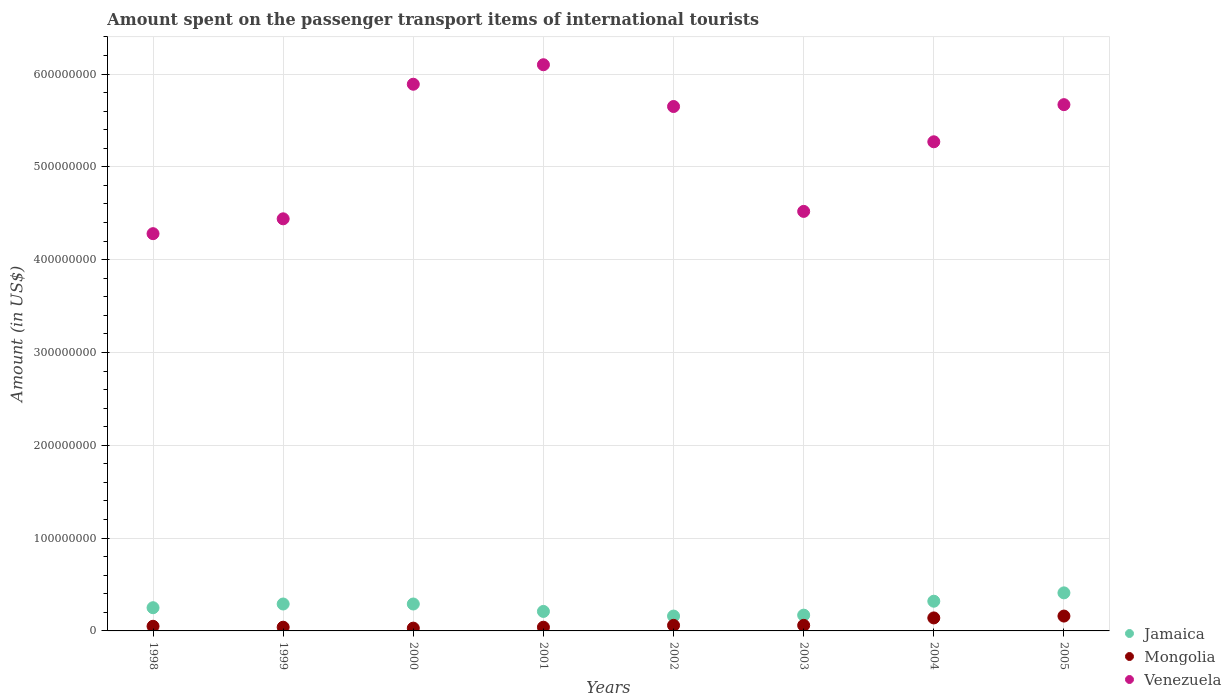How many different coloured dotlines are there?
Your response must be concise. 3. What is the amount spent on the passenger transport items of international tourists in Jamaica in 1998?
Ensure brevity in your answer.  2.50e+07. Across all years, what is the maximum amount spent on the passenger transport items of international tourists in Jamaica?
Your answer should be compact. 4.10e+07. Across all years, what is the minimum amount spent on the passenger transport items of international tourists in Jamaica?
Your answer should be very brief. 1.60e+07. In which year was the amount spent on the passenger transport items of international tourists in Venezuela minimum?
Your answer should be very brief. 1998. What is the total amount spent on the passenger transport items of international tourists in Jamaica in the graph?
Your response must be concise. 2.10e+08. What is the difference between the amount spent on the passenger transport items of international tourists in Mongolia in 2004 and the amount spent on the passenger transport items of international tourists in Jamaica in 1999?
Give a very brief answer. -1.50e+07. What is the average amount spent on the passenger transport items of international tourists in Venezuela per year?
Offer a terse response. 5.23e+08. In the year 2000, what is the difference between the amount spent on the passenger transport items of international tourists in Venezuela and amount spent on the passenger transport items of international tourists in Jamaica?
Provide a succinct answer. 5.60e+08. In how many years, is the amount spent on the passenger transport items of international tourists in Mongolia greater than 240000000 US$?
Offer a terse response. 0. What is the ratio of the amount spent on the passenger transport items of international tourists in Jamaica in 2003 to that in 2005?
Provide a short and direct response. 0.41. Is the amount spent on the passenger transport items of international tourists in Mongolia in 2000 less than that in 2002?
Make the answer very short. Yes. Is the difference between the amount spent on the passenger transport items of international tourists in Venezuela in 2000 and 2001 greater than the difference between the amount spent on the passenger transport items of international tourists in Jamaica in 2000 and 2001?
Give a very brief answer. No. What is the difference between the highest and the lowest amount spent on the passenger transport items of international tourists in Venezuela?
Give a very brief answer. 1.82e+08. Is the sum of the amount spent on the passenger transport items of international tourists in Jamaica in 2003 and 2004 greater than the maximum amount spent on the passenger transport items of international tourists in Mongolia across all years?
Your answer should be very brief. Yes. Is it the case that in every year, the sum of the amount spent on the passenger transport items of international tourists in Mongolia and amount spent on the passenger transport items of international tourists in Venezuela  is greater than the amount spent on the passenger transport items of international tourists in Jamaica?
Ensure brevity in your answer.  Yes. How many dotlines are there?
Make the answer very short. 3. Are the values on the major ticks of Y-axis written in scientific E-notation?
Your answer should be very brief. No. Does the graph contain grids?
Your response must be concise. Yes. Where does the legend appear in the graph?
Keep it short and to the point. Bottom right. How many legend labels are there?
Your answer should be compact. 3. How are the legend labels stacked?
Your answer should be very brief. Vertical. What is the title of the graph?
Offer a terse response. Amount spent on the passenger transport items of international tourists. What is the label or title of the X-axis?
Give a very brief answer. Years. What is the Amount (in US$) in Jamaica in 1998?
Your answer should be very brief. 2.50e+07. What is the Amount (in US$) of Venezuela in 1998?
Offer a terse response. 4.28e+08. What is the Amount (in US$) in Jamaica in 1999?
Provide a succinct answer. 2.90e+07. What is the Amount (in US$) in Venezuela in 1999?
Provide a short and direct response. 4.44e+08. What is the Amount (in US$) in Jamaica in 2000?
Offer a very short reply. 2.90e+07. What is the Amount (in US$) in Mongolia in 2000?
Offer a terse response. 3.00e+06. What is the Amount (in US$) of Venezuela in 2000?
Your response must be concise. 5.89e+08. What is the Amount (in US$) of Jamaica in 2001?
Your answer should be very brief. 2.10e+07. What is the Amount (in US$) in Venezuela in 2001?
Ensure brevity in your answer.  6.10e+08. What is the Amount (in US$) in Jamaica in 2002?
Ensure brevity in your answer.  1.60e+07. What is the Amount (in US$) of Mongolia in 2002?
Give a very brief answer. 6.00e+06. What is the Amount (in US$) in Venezuela in 2002?
Offer a very short reply. 5.65e+08. What is the Amount (in US$) of Jamaica in 2003?
Offer a very short reply. 1.70e+07. What is the Amount (in US$) of Mongolia in 2003?
Your answer should be compact. 6.00e+06. What is the Amount (in US$) in Venezuela in 2003?
Make the answer very short. 4.52e+08. What is the Amount (in US$) in Jamaica in 2004?
Provide a succinct answer. 3.20e+07. What is the Amount (in US$) in Mongolia in 2004?
Your answer should be compact. 1.40e+07. What is the Amount (in US$) in Venezuela in 2004?
Make the answer very short. 5.27e+08. What is the Amount (in US$) in Jamaica in 2005?
Give a very brief answer. 4.10e+07. What is the Amount (in US$) in Mongolia in 2005?
Make the answer very short. 1.60e+07. What is the Amount (in US$) in Venezuela in 2005?
Offer a terse response. 5.67e+08. Across all years, what is the maximum Amount (in US$) of Jamaica?
Your answer should be very brief. 4.10e+07. Across all years, what is the maximum Amount (in US$) in Mongolia?
Keep it short and to the point. 1.60e+07. Across all years, what is the maximum Amount (in US$) of Venezuela?
Make the answer very short. 6.10e+08. Across all years, what is the minimum Amount (in US$) in Jamaica?
Offer a very short reply. 1.60e+07. Across all years, what is the minimum Amount (in US$) in Mongolia?
Ensure brevity in your answer.  3.00e+06. Across all years, what is the minimum Amount (in US$) of Venezuela?
Provide a short and direct response. 4.28e+08. What is the total Amount (in US$) in Jamaica in the graph?
Keep it short and to the point. 2.10e+08. What is the total Amount (in US$) of Mongolia in the graph?
Your answer should be compact. 5.80e+07. What is the total Amount (in US$) of Venezuela in the graph?
Keep it short and to the point. 4.18e+09. What is the difference between the Amount (in US$) in Mongolia in 1998 and that in 1999?
Make the answer very short. 1.00e+06. What is the difference between the Amount (in US$) of Venezuela in 1998 and that in 1999?
Your response must be concise. -1.60e+07. What is the difference between the Amount (in US$) in Jamaica in 1998 and that in 2000?
Make the answer very short. -4.00e+06. What is the difference between the Amount (in US$) in Mongolia in 1998 and that in 2000?
Your response must be concise. 2.00e+06. What is the difference between the Amount (in US$) in Venezuela in 1998 and that in 2000?
Your response must be concise. -1.61e+08. What is the difference between the Amount (in US$) of Jamaica in 1998 and that in 2001?
Provide a short and direct response. 4.00e+06. What is the difference between the Amount (in US$) of Mongolia in 1998 and that in 2001?
Keep it short and to the point. 1.00e+06. What is the difference between the Amount (in US$) of Venezuela in 1998 and that in 2001?
Your answer should be compact. -1.82e+08. What is the difference between the Amount (in US$) in Jamaica in 1998 and that in 2002?
Provide a succinct answer. 9.00e+06. What is the difference between the Amount (in US$) of Venezuela in 1998 and that in 2002?
Your answer should be compact. -1.37e+08. What is the difference between the Amount (in US$) in Mongolia in 1998 and that in 2003?
Offer a very short reply. -1.00e+06. What is the difference between the Amount (in US$) of Venezuela in 1998 and that in 2003?
Ensure brevity in your answer.  -2.40e+07. What is the difference between the Amount (in US$) of Jamaica in 1998 and that in 2004?
Ensure brevity in your answer.  -7.00e+06. What is the difference between the Amount (in US$) in Mongolia in 1998 and that in 2004?
Keep it short and to the point. -9.00e+06. What is the difference between the Amount (in US$) in Venezuela in 1998 and that in 2004?
Offer a terse response. -9.90e+07. What is the difference between the Amount (in US$) in Jamaica in 1998 and that in 2005?
Offer a terse response. -1.60e+07. What is the difference between the Amount (in US$) in Mongolia in 1998 and that in 2005?
Offer a very short reply. -1.10e+07. What is the difference between the Amount (in US$) in Venezuela in 1998 and that in 2005?
Give a very brief answer. -1.39e+08. What is the difference between the Amount (in US$) of Jamaica in 1999 and that in 2000?
Offer a terse response. 0. What is the difference between the Amount (in US$) of Venezuela in 1999 and that in 2000?
Provide a succinct answer. -1.45e+08. What is the difference between the Amount (in US$) in Venezuela in 1999 and that in 2001?
Your answer should be compact. -1.66e+08. What is the difference between the Amount (in US$) of Jamaica in 1999 and that in 2002?
Offer a very short reply. 1.30e+07. What is the difference between the Amount (in US$) in Mongolia in 1999 and that in 2002?
Your response must be concise. -2.00e+06. What is the difference between the Amount (in US$) in Venezuela in 1999 and that in 2002?
Ensure brevity in your answer.  -1.21e+08. What is the difference between the Amount (in US$) of Mongolia in 1999 and that in 2003?
Offer a terse response. -2.00e+06. What is the difference between the Amount (in US$) in Venezuela in 1999 and that in 2003?
Offer a terse response. -8.00e+06. What is the difference between the Amount (in US$) in Mongolia in 1999 and that in 2004?
Your answer should be compact. -1.00e+07. What is the difference between the Amount (in US$) in Venezuela in 1999 and that in 2004?
Ensure brevity in your answer.  -8.30e+07. What is the difference between the Amount (in US$) of Jamaica in 1999 and that in 2005?
Your answer should be very brief. -1.20e+07. What is the difference between the Amount (in US$) of Mongolia in 1999 and that in 2005?
Give a very brief answer. -1.20e+07. What is the difference between the Amount (in US$) of Venezuela in 1999 and that in 2005?
Keep it short and to the point. -1.23e+08. What is the difference between the Amount (in US$) of Jamaica in 2000 and that in 2001?
Offer a terse response. 8.00e+06. What is the difference between the Amount (in US$) of Mongolia in 2000 and that in 2001?
Ensure brevity in your answer.  -1.00e+06. What is the difference between the Amount (in US$) of Venezuela in 2000 and that in 2001?
Your answer should be compact. -2.10e+07. What is the difference between the Amount (in US$) in Jamaica in 2000 and that in 2002?
Keep it short and to the point. 1.30e+07. What is the difference between the Amount (in US$) of Mongolia in 2000 and that in 2002?
Provide a succinct answer. -3.00e+06. What is the difference between the Amount (in US$) of Venezuela in 2000 and that in 2002?
Your answer should be very brief. 2.40e+07. What is the difference between the Amount (in US$) in Mongolia in 2000 and that in 2003?
Offer a terse response. -3.00e+06. What is the difference between the Amount (in US$) of Venezuela in 2000 and that in 2003?
Your answer should be compact. 1.37e+08. What is the difference between the Amount (in US$) in Mongolia in 2000 and that in 2004?
Provide a short and direct response. -1.10e+07. What is the difference between the Amount (in US$) in Venezuela in 2000 and that in 2004?
Keep it short and to the point. 6.20e+07. What is the difference between the Amount (in US$) of Jamaica in 2000 and that in 2005?
Provide a short and direct response. -1.20e+07. What is the difference between the Amount (in US$) of Mongolia in 2000 and that in 2005?
Your response must be concise. -1.30e+07. What is the difference between the Amount (in US$) in Venezuela in 2000 and that in 2005?
Your response must be concise. 2.20e+07. What is the difference between the Amount (in US$) of Jamaica in 2001 and that in 2002?
Your response must be concise. 5.00e+06. What is the difference between the Amount (in US$) of Venezuela in 2001 and that in 2002?
Provide a succinct answer. 4.50e+07. What is the difference between the Amount (in US$) of Mongolia in 2001 and that in 2003?
Offer a terse response. -2.00e+06. What is the difference between the Amount (in US$) in Venezuela in 2001 and that in 2003?
Offer a very short reply. 1.58e+08. What is the difference between the Amount (in US$) in Jamaica in 2001 and that in 2004?
Provide a short and direct response. -1.10e+07. What is the difference between the Amount (in US$) in Mongolia in 2001 and that in 2004?
Your answer should be very brief. -1.00e+07. What is the difference between the Amount (in US$) of Venezuela in 2001 and that in 2004?
Keep it short and to the point. 8.30e+07. What is the difference between the Amount (in US$) in Jamaica in 2001 and that in 2005?
Give a very brief answer. -2.00e+07. What is the difference between the Amount (in US$) in Mongolia in 2001 and that in 2005?
Your answer should be very brief. -1.20e+07. What is the difference between the Amount (in US$) in Venezuela in 2001 and that in 2005?
Your answer should be very brief. 4.30e+07. What is the difference between the Amount (in US$) in Jamaica in 2002 and that in 2003?
Offer a terse response. -1.00e+06. What is the difference between the Amount (in US$) of Venezuela in 2002 and that in 2003?
Your response must be concise. 1.13e+08. What is the difference between the Amount (in US$) of Jamaica in 2002 and that in 2004?
Offer a very short reply. -1.60e+07. What is the difference between the Amount (in US$) of Mongolia in 2002 and that in 2004?
Your response must be concise. -8.00e+06. What is the difference between the Amount (in US$) of Venezuela in 2002 and that in 2004?
Offer a very short reply. 3.80e+07. What is the difference between the Amount (in US$) of Jamaica in 2002 and that in 2005?
Your answer should be very brief. -2.50e+07. What is the difference between the Amount (in US$) in Mongolia in 2002 and that in 2005?
Give a very brief answer. -1.00e+07. What is the difference between the Amount (in US$) in Jamaica in 2003 and that in 2004?
Provide a short and direct response. -1.50e+07. What is the difference between the Amount (in US$) of Mongolia in 2003 and that in 2004?
Your answer should be very brief. -8.00e+06. What is the difference between the Amount (in US$) in Venezuela in 2003 and that in 2004?
Your answer should be compact. -7.50e+07. What is the difference between the Amount (in US$) of Jamaica in 2003 and that in 2005?
Give a very brief answer. -2.40e+07. What is the difference between the Amount (in US$) in Mongolia in 2003 and that in 2005?
Keep it short and to the point. -1.00e+07. What is the difference between the Amount (in US$) of Venezuela in 2003 and that in 2005?
Offer a terse response. -1.15e+08. What is the difference between the Amount (in US$) of Jamaica in 2004 and that in 2005?
Give a very brief answer. -9.00e+06. What is the difference between the Amount (in US$) in Venezuela in 2004 and that in 2005?
Make the answer very short. -4.00e+07. What is the difference between the Amount (in US$) in Jamaica in 1998 and the Amount (in US$) in Mongolia in 1999?
Your answer should be compact. 2.10e+07. What is the difference between the Amount (in US$) in Jamaica in 1998 and the Amount (in US$) in Venezuela in 1999?
Give a very brief answer. -4.19e+08. What is the difference between the Amount (in US$) in Mongolia in 1998 and the Amount (in US$) in Venezuela in 1999?
Provide a short and direct response. -4.39e+08. What is the difference between the Amount (in US$) in Jamaica in 1998 and the Amount (in US$) in Mongolia in 2000?
Offer a terse response. 2.20e+07. What is the difference between the Amount (in US$) of Jamaica in 1998 and the Amount (in US$) of Venezuela in 2000?
Provide a short and direct response. -5.64e+08. What is the difference between the Amount (in US$) of Mongolia in 1998 and the Amount (in US$) of Venezuela in 2000?
Offer a very short reply. -5.84e+08. What is the difference between the Amount (in US$) in Jamaica in 1998 and the Amount (in US$) in Mongolia in 2001?
Give a very brief answer. 2.10e+07. What is the difference between the Amount (in US$) of Jamaica in 1998 and the Amount (in US$) of Venezuela in 2001?
Offer a very short reply. -5.85e+08. What is the difference between the Amount (in US$) in Mongolia in 1998 and the Amount (in US$) in Venezuela in 2001?
Make the answer very short. -6.05e+08. What is the difference between the Amount (in US$) in Jamaica in 1998 and the Amount (in US$) in Mongolia in 2002?
Your answer should be very brief. 1.90e+07. What is the difference between the Amount (in US$) of Jamaica in 1998 and the Amount (in US$) of Venezuela in 2002?
Ensure brevity in your answer.  -5.40e+08. What is the difference between the Amount (in US$) in Mongolia in 1998 and the Amount (in US$) in Venezuela in 2002?
Provide a succinct answer. -5.60e+08. What is the difference between the Amount (in US$) in Jamaica in 1998 and the Amount (in US$) in Mongolia in 2003?
Your answer should be compact. 1.90e+07. What is the difference between the Amount (in US$) of Jamaica in 1998 and the Amount (in US$) of Venezuela in 2003?
Provide a short and direct response. -4.27e+08. What is the difference between the Amount (in US$) of Mongolia in 1998 and the Amount (in US$) of Venezuela in 2003?
Give a very brief answer. -4.47e+08. What is the difference between the Amount (in US$) of Jamaica in 1998 and the Amount (in US$) of Mongolia in 2004?
Provide a succinct answer. 1.10e+07. What is the difference between the Amount (in US$) in Jamaica in 1998 and the Amount (in US$) in Venezuela in 2004?
Keep it short and to the point. -5.02e+08. What is the difference between the Amount (in US$) of Mongolia in 1998 and the Amount (in US$) of Venezuela in 2004?
Make the answer very short. -5.22e+08. What is the difference between the Amount (in US$) in Jamaica in 1998 and the Amount (in US$) in Mongolia in 2005?
Provide a succinct answer. 9.00e+06. What is the difference between the Amount (in US$) of Jamaica in 1998 and the Amount (in US$) of Venezuela in 2005?
Keep it short and to the point. -5.42e+08. What is the difference between the Amount (in US$) of Mongolia in 1998 and the Amount (in US$) of Venezuela in 2005?
Keep it short and to the point. -5.62e+08. What is the difference between the Amount (in US$) of Jamaica in 1999 and the Amount (in US$) of Mongolia in 2000?
Your answer should be compact. 2.60e+07. What is the difference between the Amount (in US$) in Jamaica in 1999 and the Amount (in US$) in Venezuela in 2000?
Offer a very short reply. -5.60e+08. What is the difference between the Amount (in US$) in Mongolia in 1999 and the Amount (in US$) in Venezuela in 2000?
Provide a succinct answer. -5.85e+08. What is the difference between the Amount (in US$) of Jamaica in 1999 and the Amount (in US$) of Mongolia in 2001?
Ensure brevity in your answer.  2.50e+07. What is the difference between the Amount (in US$) in Jamaica in 1999 and the Amount (in US$) in Venezuela in 2001?
Provide a succinct answer. -5.81e+08. What is the difference between the Amount (in US$) in Mongolia in 1999 and the Amount (in US$) in Venezuela in 2001?
Your answer should be compact. -6.06e+08. What is the difference between the Amount (in US$) of Jamaica in 1999 and the Amount (in US$) of Mongolia in 2002?
Offer a very short reply. 2.30e+07. What is the difference between the Amount (in US$) of Jamaica in 1999 and the Amount (in US$) of Venezuela in 2002?
Provide a succinct answer. -5.36e+08. What is the difference between the Amount (in US$) in Mongolia in 1999 and the Amount (in US$) in Venezuela in 2002?
Give a very brief answer. -5.61e+08. What is the difference between the Amount (in US$) in Jamaica in 1999 and the Amount (in US$) in Mongolia in 2003?
Offer a terse response. 2.30e+07. What is the difference between the Amount (in US$) of Jamaica in 1999 and the Amount (in US$) of Venezuela in 2003?
Offer a very short reply. -4.23e+08. What is the difference between the Amount (in US$) in Mongolia in 1999 and the Amount (in US$) in Venezuela in 2003?
Offer a very short reply. -4.48e+08. What is the difference between the Amount (in US$) of Jamaica in 1999 and the Amount (in US$) of Mongolia in 2004?
Your answer should be compact. 1.50e+07. What is the difference between the Amount (in US$) in Jamaica in 1999 and the Amount (in US$) in Venezuela in 2004?
Make the answer very short. -4.98e+08. What is the difference between the Amount (in US$) in Mongolia in 1999 and the Amount (in US$) in Venezuela in 2004?
Your answer should be compact. -5.23e+08. What is the difference between the Amount (in US$) of Jamaica in 1999 and the Amount (in US$) of Mongolia in 2005?
Provide a short and direct response. 1.30e+07. What is the difference between the Amount (in US$) of Jamaica in 1999 and the Amount (in US$) of Venezuela in 2005?
Make the answer very short. -5.38e+08. What is the difference between the Amount (in US$) in Mongolia in 1999 and the Amount (in US$) in Venezuela in 2005?
Make the answer very short. -5.63e+08. What is the difference between the Amount (in US$) in Jamaica in 2000 and the Amount (in US$) in Mongolia in 2001?
Provide a short and direct response. 2.50e+07. What is the difference between the Amount (in US$) of Jamaica in 2000 and the Amount (in US$) of Venezuela in 2001?
Ensure brevity in your answer.  -5.81e+08. What is the difference between the Amount (in US$) in Mongolia in 2000 and the Amount (in US$) in Venezuela in 2001?
Keep it short and to the point. -6.07e+08. What is the difference between the Amount (in US$) in Jamaica in 2000 and the Amount (in US$) in Mongolia in 2002?
Your response must be concise. 2.30e+07. What is the difference between the Amount (in US$) of Jamaica in 2000 and the Amount (in US$) of Venezuela in 2002?
Provide a succinct answer. -5.36e+08. What is the difference between the Amount (in US$) of Mongolia in 2000 and the Amount (in US$) of Venezuela in 2002?
Provide a succinct answer. -5.62e+08. What is the difference between the Amount (in US$) of Jamaica in 2000 and the Amount (in US$) of Mongolia in 2003?
Offer a terse response. 2.30e+07. What is the difference between the Amount (in US$) in Jamaica in 2000 and the Amount (in US$) in Venezuela in 2003?
Give a very brief answer. -4.23e+08. What is the difference between the Amount (in US$) in Mongolia in 2000 and the Amount (in US$) in Venezuela in 2003?
Give a very brief answer. -4.49e+08. What is the difference between the Amount (in US$) of Jamaica in 2000 and the Amount (in US$) of Mongolia in 2004?
Offer a very short reply. 1.50e+07. What is the difference between the Amount (in US$) in Jamaica in 2000 and the Amount (in US$) in Venezuela in 2004?
Keep it short and to the point. -4.98e+08. What is the difference between the Amount (in US$) of Mongolia in 2000 and the Amount (in US$) of Venezuela in 2004?
Keep it short and to the point. -5.24e+08. What is the difference between the Amount (in US$) of Jamaica in 2000 and the Amount (in US$) of Mongolia in 2005?
Ensure brevity in your answer.  1.30e+07. What is the difference between the Amount (in US$) of Jamaica in 2000 and the Amount (in US$) of Venezuela in 2005?
Ensure brevity in your answer.  -5.38e+08. What is the difference between the Amount (in US$) of Mongolia in 2000 and the Amount (in US$) of Venezuela in 2005?
Your answer should be compact. -5.64e+08. What is the difference between the Amount (in US$) of Jamaica in 2001 and the Amount (in US$) of Mongolia in 2002?
Your answer should be very brief. 1.50e+07. What is the difference between the Amount (in US$) of Jamaica in 2001 and the Amount (in US$) of Venezuela in 2002?
Offer a very short reply. -5.44e+08. What is the difference between the Amount (in US$) of Mongolia in 2001 and the Amount (in US$) of Venezuela in 2002?
Your answer should be compact. -5.61e+08. What is the difference between the Amount (in US$) in Jamaica in 2001 and the Amount (in US$) in Mongolia in 2003?
Your answer should be very brief. 1.50e+07. What is the difference between the Amount (in US$) of Jamaica in 2001 and the Amount (in US$) of Venezuela in 2003?
Ensure brevity in your answer.  -4.31e+08. What is the difference between the Amount (in US$) in Mongolia in 2001 and the Amount (in US$) in Venezuela in 2003?
Offer a terse response. -4.48e+08. What is the difference between the Amount (in US$) in Jamaica in 2001 and the Amount (in US$) in Venezuela in 2004?
Give a very brief answer. -5.06e+08. What is the difference between the Amount (in US$) of Mongolia in 2001 and the Amount (in US$) of Venezuela in 2004?
Keep it short and to the point. -5.23e+08. What is the difference between the Amount (in US$) in Jamaica in 2001 and the Amount (in US$) in Venezuela in 2005?
Offer a terse response. -5.46e+08. What is the difference between the Amount (in US$) in Mongolia in 2001 and the Amount (in US$) in Venezuela in 2005?
Offer a very short reply. -5.63e+08. What is the difference between the Amount (in US$) in Jamaica in 2002 and the Amount (in US$) in Mongolia in 2003?
Offer a terse response. 1.00e+07. What is the difference between the Amount (in US$) in Jamaica in 2002 and the Amount (in US$) in Venezuela in 2003?
Offer a terse response. -4.36e+08. What is the difference between the Amount (in US$) of Mongolia in 2002 and the Amount (in US$) of Venezuela in 2003?
Keep it short and to the point. -4.46e+08. What is the difference between the Amount (in US$) in Jamaica in 2002 and the Amount (in US$) in Venezuela in 2004?
Provide a succinct answer. -5.11e+08. What is the difference between the Amount (in US$) in Mongolia in 2002 and the Amount (in US$) in Venezuela in 2004?
Your answer should be compact. -5.21e+08. What is the difference between the Amount (in US$) in Jamaica in 2002 and the Amount (in US$) in Venezuela in 2005?
Give a very brief answer. -5.51e+08. What is the difference between the Amount (in US$) in Mongolia in 2002 and the Amount (in US$) in Venezuela in 2005?
Ensure brevity in your answer.  -5.61e+08. What is the difference between the Amount (in US$) of Jamaica in 2003 and the Amount (in US$) of Mongolia in 2004?
Keep it short and to the point. 3.00e+06. What is the difference between the Amount (in US$) in Jamaica in 2003 and the Amount (in US$) in Venezuela in 2004?
Keep it short and to the point. -5.10e+08. What is the difference between the Amount (in US$) in Mongolia in 2003 and the Amount (in US$) in Venezuela in 2004?
Your answer should be very brief. -5.21e+08. What is the difference between the Amount (in US$) in Jamaica in 2003 and the Amount (in US$) in Mongolia in 2005?
Ensure brevity in your answer.  1.00e+06. What is the difference between the Amount (in US$) of Jamaica in 2003 and the Amount (in US$) of Venezuela in 2005?
Keep it short and to the point. -5.50e+08. What is the difference between the Amount (in US$) of Mongolia in 2003 and the Amount (in US$) of Venezuela in 2005?
Provide a succinct answer. -5.61e+08. What is the difference between the Amount (in US$) of Jamaica in 2004 and the Amount (in US$) of Mongolia in 2005?
Your answer should be very brief. 1.60e+07. What is the difference between the Amount (in US$) in Jamaica in 2004 and the Amount (in US$) in Venezuela in 2005?
Give a very brief answer. -5.35e+08. What is the difference between the Amount (in US$) in Mongolia in 2004 and the Amount (in US$) in Venezuela in 2005?
Provide a succinct answer. -5.53e+08. What is the average Amount (in US$) of Jamaica per year?
Offer a very short reply. 2.62e+07. What is the average Amount (in US$) in Mongolia per year?
Your answer should be compact. 7.25e+06. What is the average Amount (in US$) in Venezuela per year?
Make the answer very short. 5.23e+08. In the year 1998, what is the difference between the Amount (in US$) in Jamaica and Amount (in US$) in Mongolia?
Provide a short and direct response. 2.00e+07. In the year 1998, what is the difference between the Amount (in US$) in Jamaica and Amount (in US$) in Venezuela?
Provide a succinct answer. -4.03e+08. In the year 1998, what is the difference between the Amount (in US$) in Mongolia and Amount (in US$) in Venezuela?
Offer a terse response. -4.23e+08. In the year 1999, what is the difference between the Amount (in US$) in Jamaica and Amount (in US$) in Mongolia?
Your answer should be very brief. 2.50e+07. In the year 1999, what is the difference between the Amount (in US$) in Jamaica and Amount (in US$) in Venezuela?
Offer a terse response. -4.15e+08. In the year 1999, what is the difference between the Amount (in US$) in Mongolia and Amount (in US$) in Venezuela?
Provide a short and direct response. -4.40e+08. In the year 2000, what is the difference between the Amount (in US$) in Jamaica and Amount (in US$) in Mongolia?
Provide a succinct answer. 2.60e+07. In the year 2000, what is the difference between the Amount (in US$) in Jamaica and Amount (in US$) in Venezuela?
Offer a very short reply. -5.60e+08. In the year 2000, what is the difference between the Amount (in US$) of Mongolia and Amount (in US$) of Venezuela?
Make the answer very short. -5.86e+08. In the year 2001, what is the difference between the Amount (in US$) of Jamaica and Amount (in US$) of Mongolia?
Your answer should be very brief. 1.70e+07. In the year 2001, what is the difference between the Amount (in US$) of Jamaica and Amount (in US$) of Venezuela?
Keep it short and to the point. -5.89e+08. In the year 2001, what is the difference between the Amount (in US$) of Mongolia and Amount (in US$) of Venezuela?
Make the answer very short. -6.06e+08. In the year 2002, what is the difference between the Amount (in US$) of Jamaica and Amount (in US$) of Mongolia?
Offer a terse response. 1.00e+07. In the year 2002, what is the difference between the Amount (in US$) in Jamaica and Amount (in US$) in Venezuela?
Your response must be concise. -5.49e+08. In the year 2002, what is the difference between the Amount (in US$) in Mongolia and Amount (in US$) in Venezuela?
Your response must be concise. -5.59e+08. In the year 2003, what is the difference between the Amount (in US$) of Jamaica and Amount (in US$) of Mongolia?
Ensure brevity in your answer.  1.10e+07. In the year 2003, what is the difference between the Amount (in US$) of Jamaica and Amount (in US$) of Venezuela?
Your answer should be compact. -4.35e+08. In the year 2003, what is the difference between the Amount (in US$) in Mongolia and Amount (in US$) in Venezuela?
Your response must be concise. -4.46e+08. In the year 2004, what is the difference between the Amount (in US$) in Jamaica and Amount (in US$) in Mongolia?
Keep it short and to the point. 1.80e+07. In the year 2004, what is the difference between the Amount (in US$) in Jamaica and Amount (in US$) in Venezuela?
Provide a short and direct response. -4.95e+08. In the year 2004, what is the difference between the Amount (in US$) of Mongolia and Amount (in US$) of Venezuela?
Make the answer very short. -5.13e+08. In the year 2005, what is the difference between the Amount (in US$) of Jamaica and Amount (in US$) of Mongolia?
Offer a very short reply. 2.50e+07. In the year 2005, what is the difference between the Amount (in US$) of Jamaica and Amount (in US$) of Venezuela?
Ensure brevity in your answer.  -5.26e+08. In the year 2005, what is the difference between the Amount (in US$) of Mongolia and Amount (in US$) of Venezuela?
Offer a very short reply. -5.51e+08. What is the ratio of the Amount (in US$) of Jamaica in 1998 to that in 1999?
Give a very brief answer. 0.86. What is the ratio of the Amount (in US$) of Venezuela in 1998 to that in 1999?
Provide a succinct answer. 0.96. What is the ratio of the Amount (in US$) of Jamaica in 1998 to that in 2000?
Keep it short and to the point. 0.86. What is the ratio of the Amount (in US$) of Venezuela in 1998 to that in 2000?
Give a very brief answer. 0.73. What is the ratio of the Amount (in US$) of Jamaica in 1998 to that in 2001?
Ensure brevity in your answer.  1.19. What is the ratio of the Amount (in US$) in Mongolia in 1998 to that in 2001?
Offer a terse response. 1.25. What is the ratio of the Amount (in US$) in Venezuela in 1998 to that in 2001?
Provide a short and direct response. 0.7. What is the ratio of the Amount (in US$) of Jamaica in 1998 to that in 2002?
Offer a very short reply. 1.56. What is the ratio of the Amount (in US$) in Venezuela in 1998 to that in 2002?
Keep it short and to the point. 0.76. What is the ratio of the Amount (in US$) of Jamaica in 1998 to that in 2003?
Your answer should be very brief. 1.47. What is the ratio of the Amount (in US$) of Venezuela in 1998 to that in 2003?
Provide a short and direct response. 0.95. What is the ratio of the Amount (in US$) of Jamaica in 1998 to that in 2004?
Offer a very short reply. 0.78. What is the ratio of the Amount (in US$) of Mongolia in 1998 to that in 2004?
Keep it short and to the point. 0.36. What is the ratio of the Amount (in US$) of Venezuela in 1998 to that in 2004?
Ensure brevity in your answer.  0.81. What is the ratio of the Amount (in US$) of Jamaica in 1998 to that in 2005?
Offer a terse response. 0.61. What is the ratio of the Amount (in US$) in Mongolia in 1998 to that in 2005?
Your response must be concise. 0.31. What is the ratio of the Amount (in US$) in Venezuela in 1998 to that in 2005?
Your answer should be very brief. 0.75. What is the ratio of the Amount (in US$) in Jamaica in 1999 to that in 2000?
Your answer should be very brief. 1. What is the ratio of the Amount (in US$) of Venezuela in 1999 to that in 2000?
Offer a very short reply. 0.75. What is the ratio of the Amount (in US$) in Jamaica in 1999 to that in 2001?
Offer a terse response. 1.38. What is the ratio of the Amount (in US$) in Mongolia in 1999 to that in 2001?
Offer a terse response. 1. What is the ratio of the Amount (in US$) in Venezuela in 1999 to that in 2001?
Offer a very short reply. 0.73. What is the ratio of the Amount (in US$) of Jamaica in 1999 to that in 2002?
Give a very brief answer. 1.81. What is the ratio of the Amount (in US$) of Venezuela in 1999 to that in 2002?
Offer a terse response. 0.79. What is the ratio of the Amount (in US$) in Jamaica in 1999 to that in 2003?
Your answer should be very brief. 1.71. What is the ratio of the Amount (in US$) of Venezuela in 1999 to that in 2003?
Offer a terse response. 0.98. What is the ratio of the Amount (in US$) in Jamaica in 1999 to that in 2004?
Your answer should be very brief. 0.91. What is the ratio of the Amount (in US$) of Mongolia in 1999 to that in 2004?
Provide a short and direct response. 0.29. What is the ratio of the Amount (in US$) of Venezuela in 1999 to that in 2004?
Offer a very short reply. 0.84. What is the ratio of the Amount (in US$) of Jamaica in 1999 to that in 2005?
Your answer should be compact. 0.71. What is the ratio of the Amount (in US$) of Venezuela in 1999 to that in 2005?
Keep it short and to the point. 0.78. What is the ratio of the Amount (in US$) in Jamaica in 2000 to that in 2001?
Ensure brevity in your answer.  1.38. What is the ratio of the Amount (in US$) of Venezuela in 2000 to that in 2001?
Your response must be concise. 0.97. What is the ratio of the Amount (in US$) of Jamaica in 2000 to that in 2002?
Offer a very short reply. 1.81. What is the ratio of the Amount (in US$) in Mongolia in 2000 to that in 2002?
Offer a terse response. 0.5. What is the ratio of the Amount (in US$) in Venezuela in 2000 to that in 2002?
Offer a very short reply. 1.04. What is the ratio of the Amount (in US$) in Jamaica in 2000 to that in 2003?
Your answer should be compact. 1.71. What is the ratio of the Amount (in US$) in Venezuela in 2000 to that in 2003?
Your response must be concise. 1.3. What is the ratio of the Amount (in US$) of Jamaica in 2000 to that in 2004?
Your answer should be very brief. 0.91. What is the ratio of the Amount (in US$) of Mongolia in 2000 to that in 2004?
Offer a terse response. 0.21. What is the ratio of the Amount (in US$) of Venezuela in 2000 to that in 2004?
Your answer should be compact. 1.12. What is the ratio of the Amount (in US$) in Jamaica in 2000 to that in 2005?
Offer a very short reply. 0.71. What is the ratio of the Amount (in US$) in Mongolia in 2000 to that in 2005?
Keep it short and to the point. 0.19. What is the ratio of the Amount (in US$) of Venezuela in 2000 to that in 2005?
Your response must be concise. 1.04. What is the ratio of the Amount (in US$) of Jamaica in 2001 to that in 2002?
Ensure brevity in your answer.  1.31. What is the ratio of the Amount (in US$) in Venezuela in 2001 to that in 2002?
Offer a terse response. 1.08. What is the ratio of the Amount (in US$) of Jamaica in 2001 to that in 2003?
Your response must be concise. 1.24. What is the ratio of the Amount (in US$) in Mongolia in 2001 to that in 2003?
Your response must be concise. 0.67. What is the ratio of the Amount (in US$) in Venezuela in 2001 to that in 2003?
Ensure brevity in your answer.  1.35. What is the ratio of the Amount (in US$) in Jamaica in 2001 to that in 2004?
Your response must be concise. 0.66. What is the ratio of the Amount (in US$) in Mongolia in 2001 to that in 2004?
Offer a terse response. 0.29. What is the ratio of the Amount (in US$) of Venezuela in 2001 to that in 2004?
Your answer should be very brief. 1.16. What is the ratio of the Amount (in US$) in Jamaica in 2001 to that in 2005?
Provide a succinct answer. 0.51. What is the ratio of the Amount (in US$) in Mongolia in 2001 to that in 2005?
Provide a succinct answer. 0.25. What is the ratio of the Amount (in US$) of Venezuela in 2001 to that in 2005?
Keep it short and to the point. 1.08. What is the ratio of the Amount (in US$) of Venezuela in 2002 to that in 2003?
Give a very brief answer. 1.25. What is the ratio of the Amount (in US$) of Mongolia in 2002 to that in 2004?
Your response must be concise. 0.43. What is the ratio of the Amount (in US$) in Venezuela in 2002 to that in 2004?
Your answer should be compact. 1.07. What is the ratio of the Amount (in US$) in Jamaica in 2002 to that in 2005?
Give a very brief answer. 0.39. What is the ratio of the Amount (in US$) in Mongolia in 2002 to that in 2005?
Offer a very short reply. 0.38. What is the ratio of the Amount (in US$) in Venezuela in 2002 to that in 2005?
Provide a short and direct response. 1. What is the ratio of the Amount (in US$) of Jamaica in 2003 to that in 2004?
Give a very brief answer. 0.53. What is the ratio of the Amount (in US$) in Mongolia in 2003 to that in 2004?
Your answer should be very brief. 0.43. What is the ratio of the Amount (in US$) of Venezuela in 2003 to that in 2004?
Your response must be concise. 0.86. What is the ratio of the Amount (in US$) of Jamaica in 2003 to that in 2005?
Make the answer very short. 0.41. What is the ratio of the Amount (in US$) in Venezuela in 2003 to that in 2005?
Your answer should be very brief. 0.8. What is the ratio of the Amount (in US$) of Jamaica in 2004 to that in 2005?
Keep it short and to the point. 0.78. What is the ratio of the Amount (in US$) in Mongolia in 2004 to that in 2005?
Your response must be concise. 0.88. What is the ratio of the Amount (in US$) of Venezuela in 2004 to that in 2005?
Ensure brevity in your answer.  0.93. What is the difference between the highest and the second highest Amount (in US$) in Jamaica?
Offer a terse response. 9.00e+06. What is the difference between the highest and the second highest Amount (in US$) in Venezuela?
Give a very brief answer. 2.10e+07. What is the difference between the highest and the lowest Amount (in US$) in Jamaica?
Make the answer very short. 2.50e+07. What is the difference between the highest and the lowest Amount (in US$) of Mongolia?
Provide a short and direct response. 1.30e+07. What is the difference between the highest and the lowest Amount (in US$) in Venezuela?
Offer a terse response. 1.82e+08. 